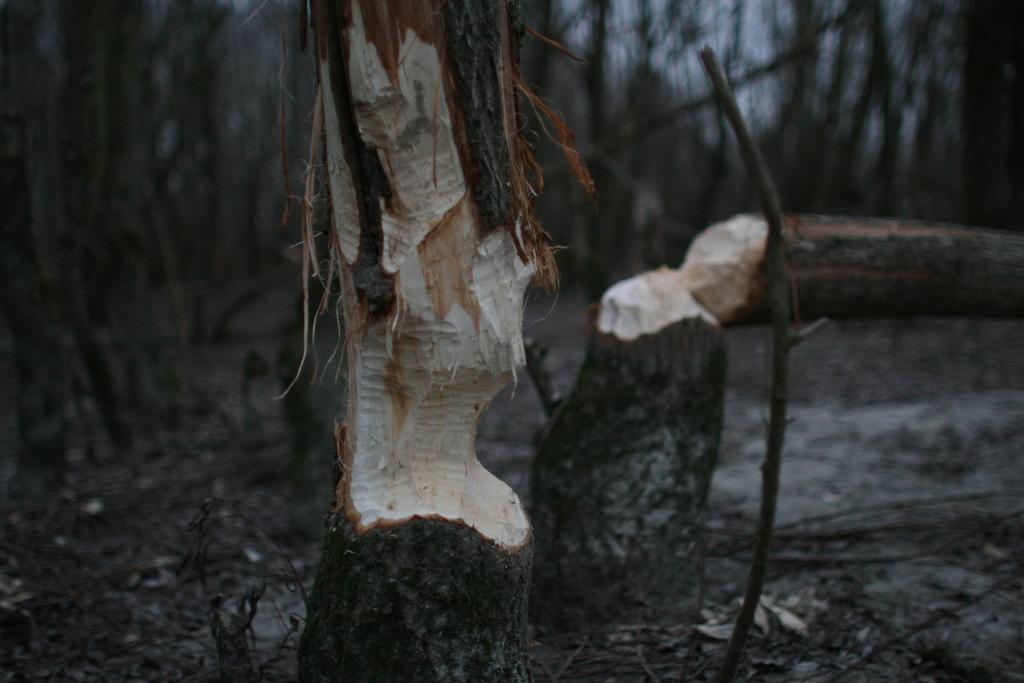In one or two sentences, can you explain what this image depicts? In this picture I can see chopped tree trunks, and there is blur background. 